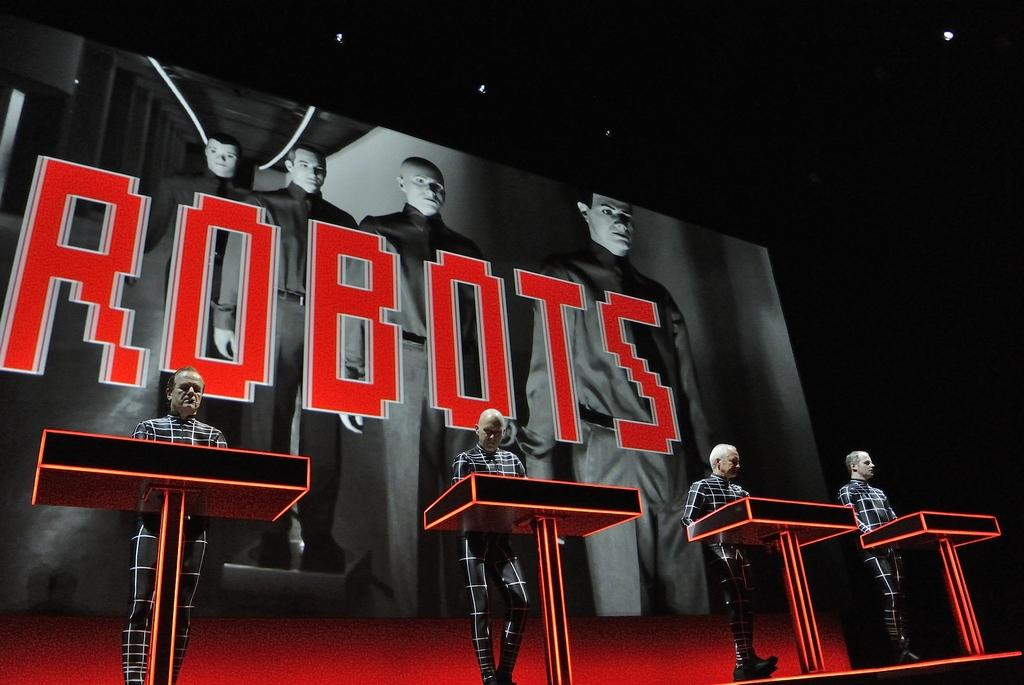What is the main subject of the image? The main subject of the image is men standing in the image. What objects are present in the image besides the men? There are podiums in the image. What can be seen in the background of the image? There is an advertisement hoarding in the background of the image. What information is displayed on the advertisement hoarding? The advertisement hoarding has text on it. What type of care can be seen being provided to the team in the image? There is no team or care being provided in the image; it features men standing near podiums with an advertisement hoarding in the background. 